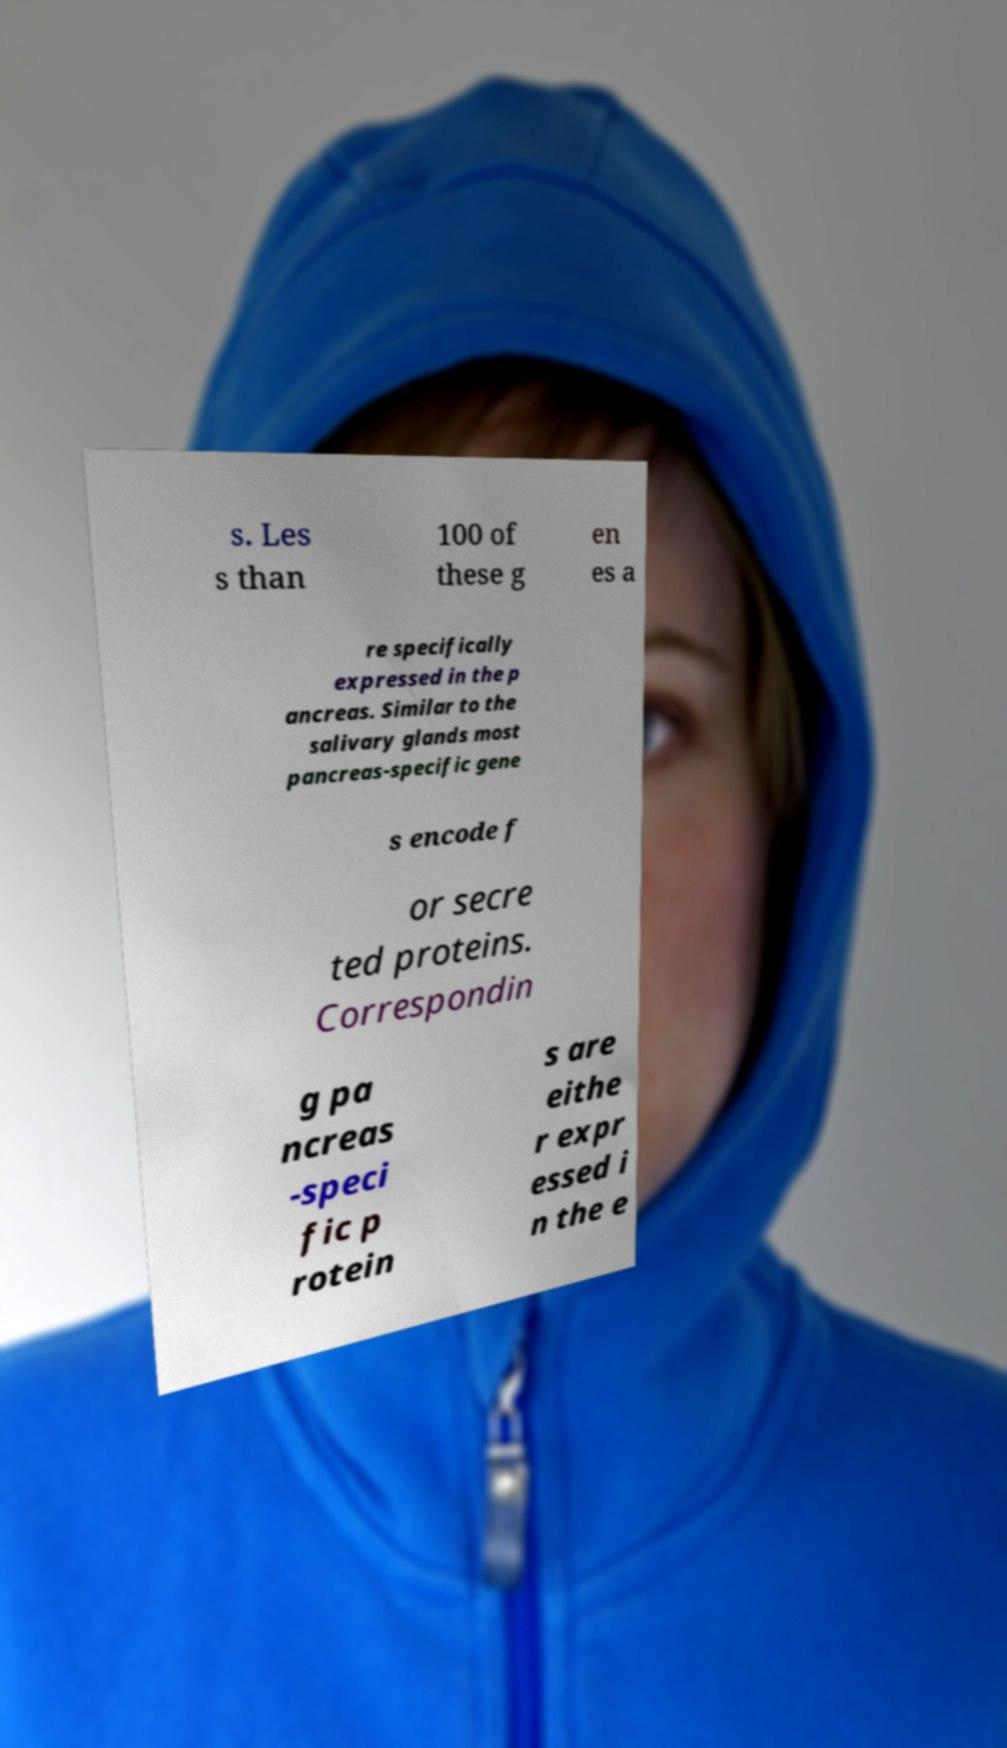I need the written content from this picture converted into text. Can you do that? s. Les s than 100 of these g en es a re specifically expressed in the p ancreas. Similar to the salivary glands most pancreas-specific gene s encode f or secre ted proteins. Correspondin g pa ncreas -speci fic p rotein s are eithe r expr essed i n the e 